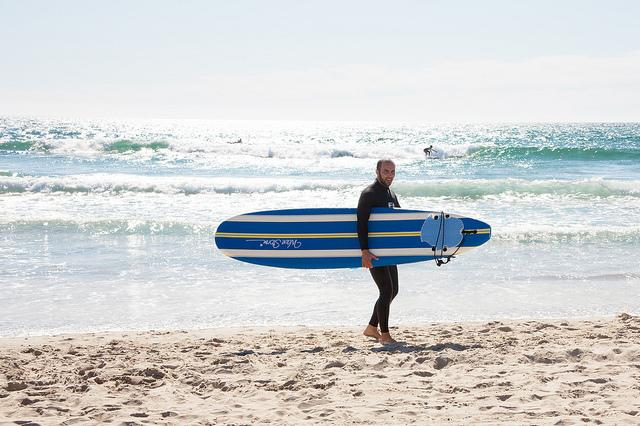What type of outfit is the man wearing?

Choices:
A) sweat suit
B) track suit
C) scuba suit
D) wet suit wet suit 